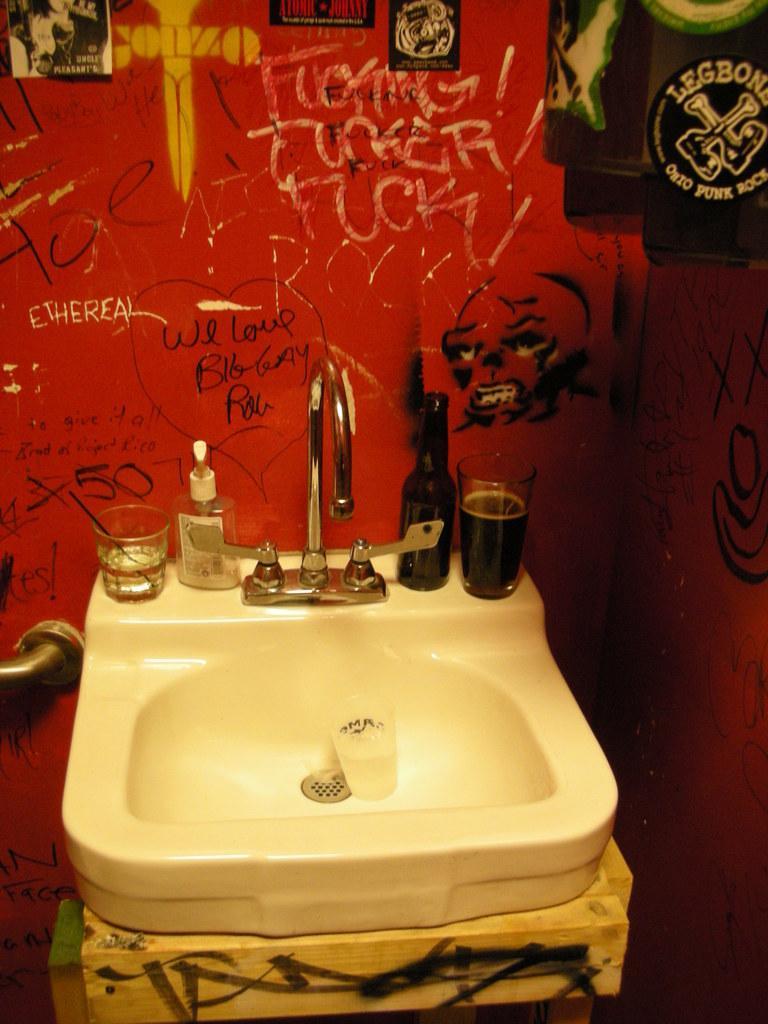Describe this image in one or two sentences. In the picture we can see a sink with a tap and with a sanitize bottle and some glass and to the walls we can see a red color and something scribbling on it. 